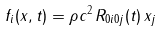Convert formula to latex. <formula><loc_0><loc_0><loc_500><loc_500>f _ { i } ( { x } , t ) = \rho c ^ { 2 } \, R _ { 0 i 0 j } ( t ) \, x _ { j }</formula> 